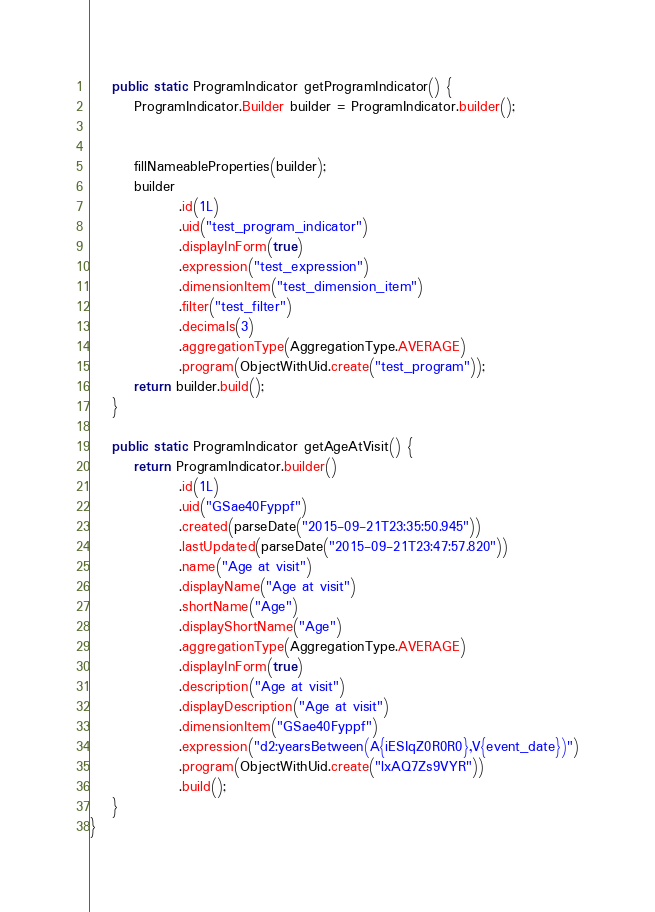<code> <loc_0><loc_0><loc_500><loc_500><_Java_>
    public static ProgramIndicator getProgramIndicator() {
        ProgramIndicator.Builder builder = ProgramIndicator.builder();


        fillNameableProperties(builder);
        builder
                .id(1L)
                .uid("test_program_indicator")
                .displayInForm(true)
                .expression("test_expression")
                .dimensionItem("test_dimension_item")
                .filter("test_filter")
                .decimals(3)
                .aggregationType(AggregationType.AVERAGE)
                .program(ObjectWithUid.create("test_program"));
        return builder.build();
    }

    public static ProgramIndicator getAgeAtVisit() {
        return ProgramIndicator.builder()
                .id(1L)
                .uid("GSae40Fyppf")
                .created(parseDate("2015-09-21T23:35:50.945"))
                .lastUpdated(parseDate("2015-09-21T23:47:57.820"))
                .name("Age at visit")
                .displayName("Age at visit")
                .shortName("Age")
                .displayShortName("Age")
                .aggregationType(AggregationType.AVERAGE)
                .displayInForm(true)
                .description("Age at visit")
                .displayDescription("Age at visit")
                .dimensionItem("GSae40Fyppf")
                .expression("d2:yearsBetween(A{iESIqZ0R0R0},V{event_date})")
                .program(ObjectWithUid.create("lxAQ7Zs9VYR"))
                .build();
    }
}</code> 